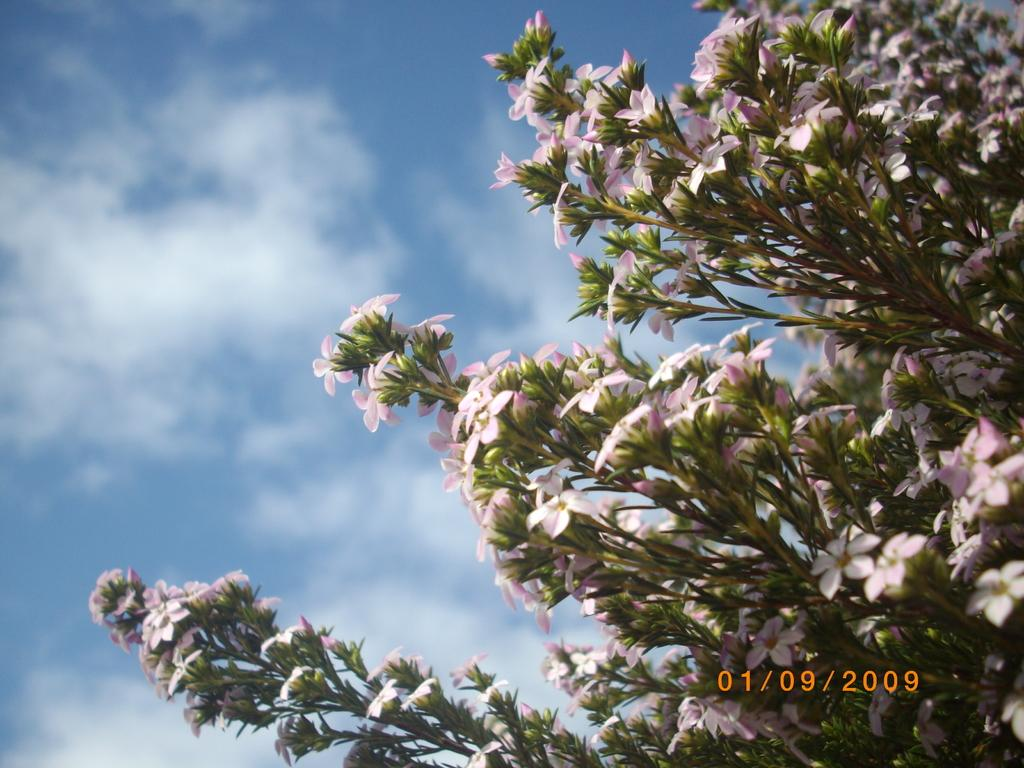What type of plants can be seen in the image? There are plants with flowers in the image. What can be seen in the background of the image? There is sky visible in the background of the image. What is present in the sky? There are clouds in the sky. How does the porter help the plants grow in the image? There is no porter present in the image, and therefore no assistance can be observed in the growth of the plants. 